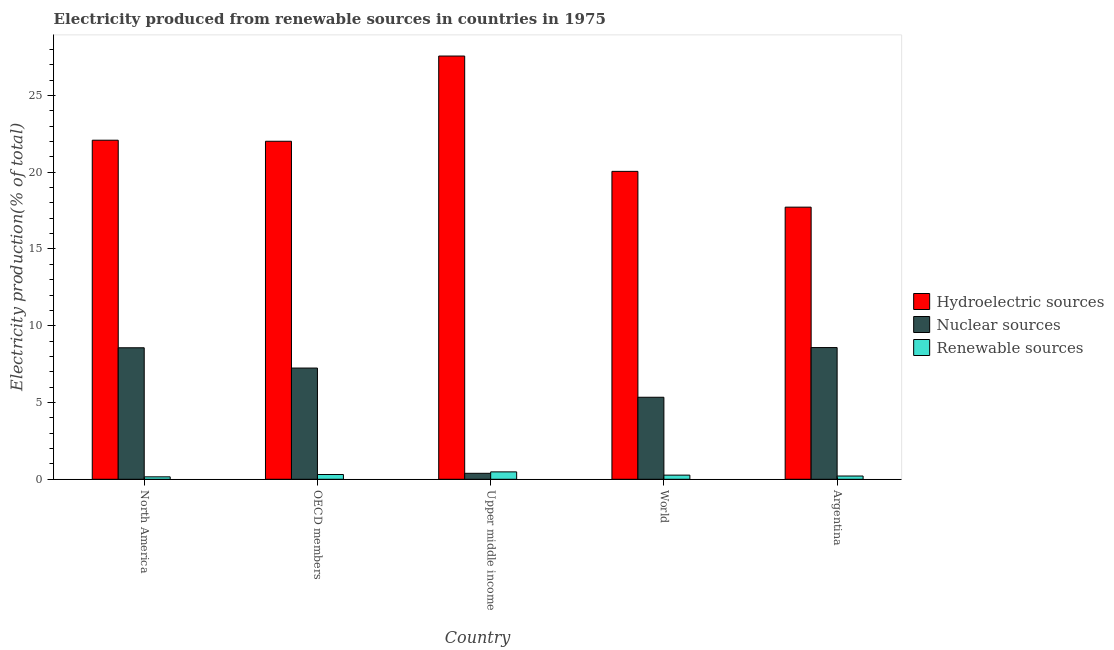Are the number of bars on each tick of the X-axis equal?
Your response must be concise. Yes. How many bars are there on the 3rd tick from the left?
Ensure brevity in your answer.  3. What is the label of the 3rd group of bars from the left?
Offer a very short reply. Upper middle income. What is the percentage of electricity produced by renewable sources in Upper middle income?
Give a very brief answer. 0.48. Across all countries, what is the maximum percentage of electricity produced by hydroelectric sources?
Your answer should be very brief. 27.57. Across all countries, what is the minimum percentage of electricity produced by renewable sources?
Your answer should be very brief. 0.16. In which country was the percentage of electricity produced by renewable sources maximum?
Give a very brief answer. Upper middle income. What is the total percentage of electricity produced by renewable sources in the graph?
Make the answer very short. 1.43. What is the difference between the percentage of electricity produced by nuclear sources in North America and that in World?
Provide a succinct answer. 3.22. What is the difference between the percentage of electricity produced by nuclear sources in Argentina and the percentage of electricity produced by renewable sources in Upper middle income?
Provide a short and direct response. 8.1. What is the average percentage of electricity produced by hydroelectric sources per country?
Give a very brief answer. 21.89. What is the difference between the percentage of electricity produced by nuclear sources and percentage of electricity produced by hydroelectric sources in OECD members?
Provide a succinct answer. -14.77. What is the ratio of the percentage of electricity produced by renewable sources in Upper middle income to that in World?
Ensure brevity in your answer.  1.79. What is the difference between the highest and the second highest percentage of electricity produced by hydroelectric sources?
Your answer should be compact. 5.48. What is the difference between the highest and the lowest percentage of electricity produced by nuclear sources?
Provide a short and direct response. 8.19. What does the 1st bar from the left in North America represents?
Make the answer very short. Hydroelectric sources. What does the 2nd bar from the right in World represents?
Give a very brief answer. Nuclear sources. Does the graph contain any zero values?
Your answer should be compact. No. Does the graph contain grids?
Give a very brief answer. No. Where does the legend appear in the graph?
Offer a very short reply. Center right. How are the legend labels stacked?
Keep it short and to the point. Vertical. What is the title of the graph?
Keep it short and to the point. Electricity produced from renewable sources in countries in 1975. Does "Services" appear as one of the legend labels in the graph?
Give a very brief answer. No. What is the Electricity production(% of total) in Hydroelectric sources in North America?
Provide a short and direct response. 22.08. What is the Electricity production(% of total) in Nuclear sources in North America?
Ensure brevity in your answer.  8.57. What is the Electricity production(% of total) of Renewable sources in North America?
Your answer should be very brief. 0.16. What is the Electricity production(% of total) of Hydroelectric sources in OECD members?
Offer a very short reply. 22.02. What is the Electricity production(% of total) of Nuclear sources in OECD members?
Keep it short and to the point. 7.24. What is the Electricity production(% of total) in Renewable sources in OECD members?
Provide a short and direct response. 0.31. What is the Electricity production(% of total) of Hydroelectric sources in Upper middle income?
Provide a succinct answer. 27.57. What is the Electricity production(% of total) of Nuclear sources in Upper middle income?
Ensure brevity in your answer.  0.39. What is the Electricity production(% of total) of Renewable sources in Upper middle income?
Keep it short and to the point. 0.48. What is the Electricity production(% of total) in Hydroelectric sources in World?
Your answer should be compact. 20.06. What is the Electricity production(% of total) of Nuclear sources in World?
Keep it short and to the point. 5.34. What is the Electricity production(% of total) in Renewable sources in World?
Make the answer very short. 0.27. What is the Electricity production(% of total) of Hydroelectric sources in Argentina?
Your answer should be very brief. 17.72. What is the Electricity production(% of total) in Nuclear sources in Argentina?
Ensure brevity in your answer.  8.58. What is the Electricity production(% of total) in Renewable sources in Argentina?
Provide a short and direct response. 0.21. Across all countries, what is the maximum Electricity production(% of total) in Hydroelectric sources?
Keep it short and to the point. 27.57. Across all countries, what is the maximum Electricity production(% of total) of Nuclear sources?
Your response must be concise. 8.58. Across all countries, what is the maximum Electricity production(% of total) in Renewable sources?
Your answer should be very brief. 0.48. Across all countries, what is the minimum Electricity production(% of total) of Hydroelectric sources?
Keep it short and to the point. 17.72. Across all countries, what is the minimum Electricity production(% of total) of Nuclear sources?
Provide a short and direct response. 0.39. Across all countries, what is the minimum Electricity production(% of total) of Renewable sources?
Your answer should be very brief. 0.16. What is the total Electricity production(% of total) in Hydroelectric sources in the graph?
Provide a succinct answer. 109.45. What is the total Electricity production(% of total) of Nuclear sources in the graph?
Offer a terse response. 30.12. What is the total Electricity production(% of total) of Renewable sources in the graph?
Give a very brief answer. 1.43. What is the difference between the Electricity production(% of total) of Hydroelectric sources in North America and that in OECD members?
Make the answer very short. 0.07. What is the difference between the Electricity production(% of total) of Nuclear sources in North America and that in OECD members?
Give a very brief answer. 1.32. What is the difference between the Electricity production(% of total) in Renewable sources in North America and that in OECD members?
Your response must be concise. -0.15. What is the difference between the Electricity production(% of total) in Hydroelectric sources in North America and that in Upper middle income?
Give a very brief answer. -5.48. What is the difference between the Electricity production(% of total) of Nuclear sources in North America and that in Upper middle income?
Provide a succinct answer. 8.18. What is the difference between the Electricity production(% of total) of Renewable sources in North America and that in Upper middle income?
Ensure brevity in your answer.  -0.32. What is the difference between the Electricity production(% of total) in Hydroelectric sources in North America and that in World?
Provide a short and direct response. 2.03. What is the difference between the Electricity production(% of total) in Nuclear sources in North America and that in World?
Give a very brief answer. 3.22. What is the difference between the Electricity production(% of total) of Renewable sources in North America and that in World?
Provide a succinct answer. -0.11. What is the difference between the Electricity production(% of total) in Hydroelectric sources in North America and that in Argentina?
Ensure brevity in your answer.  4.36. What is the difference between the Electricity production(% of total) of Nuclear sources in North America and that in Argentina?
Offer a terse response. -0.01. What is the difference between the Electricity production(% of total) in Renewable sources in North America and that in Argentina?
Offer a very short reply. -0.05. What is the difference between the Electricity production(% of total) in Hydroelectric sources in OECD members and that in Upper middle income?
Offer a very short reply. -5.55. What is the difference between the Electricity production(% of total) of Nuclear sources in OECD members and that in Upper middle income?
Offer a terse response. 6.85. What is the difference between the Electricity production(% of total) of Renewable sources in OECD members and that in Upper middle income?
Your answer should be very brief. -0.17. What is the difference between the Electricity production(% of total) of Hydroelectric sources in OECD members and that in World?
Keep it short and to the point. 1.96. What is the difference between the Electricity production(% of total) in Nuclear sources in OECD members and that in World?
Provide a succinct answer. 1.9. What is the difference between the Electricity production(% of total) in Renewable sources in OECD members and that in World?
Your response must be concise. 0.04. What is the difference between the Electricity production(% of total) in Hydroelectric sources in OECD members and that in Argentina?
Keep it short and to the point. 4.29. What is the difference between the Electricity production(% of total) in Nuclear sources in OECD members and that in Argentina?
Offer a terse response. -1.33. What is the difference between the Electricity production(% of total) in Renewable sources in OECD members and that in Argentina?
Provide a succinct answer. 0.1. What is the difference between the Electricity production(% of total) of Hydroelectric sources in Upper middle income and that in World?
Keep it short and to the point. 7.51. What is the difference between the Electricity production(% of total) in Nuclear sources in Upper middle income and that in World?
Give a very brief answer. -4.95. What is the difference between the Electricity production(% of total) in Renewable sources in Upper middle income and that in World?
Keep it short and to the point. 0.21. What is the difference between the Electricity production(% of total) in Hydroelectric sources in Upper middle income and that in Argentina?
Provide a succinct answer. 9.84. What is the difference between the Electricity production(% of total) of Nuclear sources in Upper middle income and that in Argentina?
Your answer should be very brief. -8.19. What is the difference between the Electricity production(% of total) of Renewable sources in Upper middle income and that in Argentina?
Offer a terse response. 0.27. What is the difference between the Electricity production(% of total) of Hydroelectric sources in World and that in Argentina?
Offer a very short reply. 2.33. What is the difference between the Electricity production(% of total) of Nuclear sources in World and that in Argentina?
Your answer should be compact. -3.24. What is the difference between the Electricity production(% of total) in Renewable sources in World and that in Argentina?
Ensure brevity in your answer.  0.06. What is the difference between the Electricity production(% of total) in Hydroelectric sources in North America and the Electricity production(% of total) in Nuclear sources in OECD members?
Provide a short and direct response. 14.84. What is the difference between the Electricity production(% of total) in Hydroelectric sources in North America and the Electricity production(% of total) in Renewable sources in OECD members?
Make the answer very short. 21.77. What is the difference between the Electricity production(% of total) of Nuclear sources in North America and the Electricity production(% of total) of Renewable sources in OECD members?
Provide a succinct answer. 8.25. What is the difference between the Electricity production(% of total) in Hydroelectric sources in North America and the Electricity production(% of total) in Nuclear sources in Upper middle income?
Make the answer very short. 21.7. What is the difference between the Electricity production(% of total) of Hydroelectric sources in North America and the Electricity production(% of total) of Renewable sources in Upper middle income?
Ensure brevity in your answer.  21.6. What is the difference between the Electricity production(% of total) of Nuclear sources in North America and the Electricity production(% of total) of Renewable sources in Upper middle income?
Your answer should be compact. 8.08. What is the difference between the Electricity production(% of total) of Hydroelectric sources in North America and the Electricity production(% of total) of Nuclear sources in World?
Provide a succinct answer. 16.74. What is the difference between the Electricity production(% of total) in Hydroelectric sources in North America and the Electricity production(% of total) in Renewable sources in World?
Make the answer very short. 21.81. What is the difference between the Electricity production(% of total) of Nuclear sources in North America and the Electricity production(% of total) of Renewable sources in World?
Your answer should be compact. 8.3. What is the difference between the Electricity production(% of total) of Hydroelectric sources in North America and the Electricity production(% of total) of Nuclear sources in Argentina?
Your answer should be very brief. 13.51. What is the difference between the Electricity production(% of total) of Hydroelectric sources in North America and the Electricity production(% of total) of Renewable sources in Argentina?
Your answer should be very brief. 21.87. What is the difference between the Electricity production(% of total) of Nuclear sources in North America and the Electricity production(% of total) of Renewable sources in Argentina?
Offer a very short reply. 8.35. What is the difference between the Electricity production(% of total) in Hydroelectric sources in OECD members and the Electricity production(% of total) in Nuclear sources in Upper middle income?
Give a very brief answer. 21.63. What is the difference between the Electricity production(% of total) of Hydroelectric sources in OECD members and the Electricity production(% of total) of Renewable sources in Upper middle income?
Offer a terse response. 21.53. What is the difference between the Electricity production(% of total) in Nuclear sources in OECD members and the Electricity production(% of total) in Renewable sources in Upper middle income?
Your response must be concise. 6.76. What is the difference between the Electricity production(% of total) in Hydroelectric sources in OECD members and the Electricity production(% of total) in Nuclear sources in World?
Your answer should be very brief. 16.67. What is the difference between the Electricity production(% of total) in Hydroelectric sources in OECD members and the Electricity production(% of total) in Renewable sources in World?
Ensure brevity in your answer.  21.75. What is the difference between the Electricity production(% of total) in Nuclear sources in OECD members and the Electricity production(% of total) in Renewable sources in World?
Offer a terse response. 6.97. What is the difference between the Electricity production(% of total) of Hydroelectric sources in OECD members and the Electricity production(% of total) of Nuclear sources in Argentina?
Offer a terse response. 13.44. What is the difference between the Electricity production(% of total) of Hydroelectric sources in OECD members and the Electricity production(% of total) of Renewable sources in Argentina?
Your answer should be very brief. 21.8. What is the difference between the Electricity production(% of total) in Nuclear sources in OECD members and the Electricity production(% of total) in Renewable sources in Argentina?
Make the answer very short. 7.03. What is the difference between the Electricity production(% of total) in Hydroelectric sources in Upper middle income and the Electricity production(% of total) in Nuclear sources in World?
Offer a very short reply. 22.23. What is the difference between the Electricity production(% of total) in Hydroelectric sources in Upper middle income and the Electricity production(% of total) in Renewable sources in World?
Your answer should be very brief. 27.3. What is the difference between the Electricity production(% of total) in Nuclear sources in Upper middle income and the Electricity production(% of total) in Renewable sources in World?
Your response must be concise. 0.12. What is the difference between the Electricity production(% of total) in Hydroelectric sources in Upper middle income and the Electricity production(% of total) in Nuclear sources in Argentina?
Provide a short and direct response. 18.99. What is the difference between the Electricity production(% of total) in Hydroelectric sources in Upper middle income and the Electricity production(% of total) in Renewable sources in Argentina?
Give a very brief answer. 27.36. What is the difference between the Electricity production(% of total) in Nuclear sources in Upper middle income and the Electricity production(% of total) in Renewable sources in Argentina?
Make the answer very short. 0.18. What is the difference between the Electricity production(% of total) of Hydroelectric sources in World and the Electricity production(% of total) of Nuclear sources in Argentina?
Keep it short and to the point. 11.48. What is the difference between the Electricity production(% of total) of Hydroelectric sources in World and the Electricity production(% of total) of Renewable sources in Argentina?
Offer a terse response. 19.84. What is the difference between the Electricity production(% of total) of Nuclear sources in World and the Electricity production(% of total) of Renewable sources in Argentina?
Offer a very short reply. 5.13. What is the average Electricity production(% of total) in Hydroelectric sources per country?
Ensure brevity in your answer.  21.89. What is the average Electricity production(% of total) of Nuclear sources per country?
Offer a terse response. 6.02. What is the average Electricity production(% of total) of Renewable sources per country?
Offer a terse response. 0.29. What is the difference between the Electricity production(% of total) of Hydroelectric sources and Electricity production(% of total) of Nuclear sources in North America?
Offer a very short reply. 13.52. What is the difference between the Electricity production(% of total) in Hydroelectric sources and Electricity production(% of total) in Renewable sources in North America?
Your answer should be very brief. 21.93. What is the difference between the Electricity production(% of total) of Nuclear sources and Electricity production(% of total) of Renewable sources in North America?
Your answer should be very brief. 8.41. What is the difference between the Electricity production(% of total) in Hydroelectric sources and Electricity production(% of total) in Nuclear sources in OECD members?
Your answer should be compact. 14.77. What is the difference between the Electricity production(% of total) of Hydroelectric sources and Electricity production(% of total) of Renewable sources in OECD members?
Offer a terse response. 21.7. What is the difference between the Electricity production(% of total) in Nuclear sources and Electricity production(% of total) in Renewable sources in OECD members?
Your answer should be very brief. 6.93. What is the difference between the Electricity production(% of total) in Hydroelectric sources and Electricity production(% of total) in Nuclear sources in Upper middle income?
Your answer should be compact. 27.18. What is the difference between the Electricity production(% of total) in Hydroelectric sources and Electricity production(% of total) in Renewable sources in Upper middle income?
Provide a succinct answer. 27.09. What is the difference between the Electricity production(% of total) of Nuclear sources and Electricity production(% of total) of Renewable sources in Upper middle income?
Make the answer very short. -0.09. What is the difference between the Electricity production(% of total) of Hydroelectric sources and Electricity production(% of total) of Nuclear sources in World?
Give a very brief answer. 14.71. What is the difference between the Electricity production(% of total) of Hydroelectric sources and Electricity production(% of total) of Renewable sources in World?
Ensure brevity in your answer.  19.79. What is the difference between the Electricity production(% of total) of Nuclear sources and Electricity production(% of total) of Renewable sources in World?
Make the answer very short. 5.07. What is the difference between the Electricity production(% of total) in Hydroelectric sources and Electricity production(% of total) in Nuclear sources in Argentina?
Your response must be concise. 9.15. What is the difference between the Electricity production(% of total) in Hydroelectric sources and Electricity production(% of total) in Renewable sources in Argentina?
Make the answer very short. 17.51. What is the difference between the Electricity production(% of total) of Nuclear sources and Electricity production(% of total) of Renewable sources in Argentina?
Offer a terse response. 8.37. What is the ratio of the Electricity production(% of total) in Nuclear sources in North America to that in OECD members?
Give a very brief answer. 1.18. What is the ratio of the Electricity production(% of total) in Renewable sources in North America to that in OECD members?
Give a very brief answer. 0.51. What is the ratio of the Electricity production(% of total) of Hydroelectric sources in North America to that in Upper middle income?
Offer a very short reply. 0.8. What is the ratio of the Electricity production(% of total) of Nuclear sources in North America to that in Upper middle income?
Offer a terse response. 22.02. What is the ratio of the Electricity production(% of total) in Renewable sources in North America to that in Upper middle income?
Provide a succinct answer. 0.33. What is the ratio of the Electricity production(% of total) of Hydroelectric sources in North America to that in World?
Provide a short and direct response. 1.1. What is the ratio of the Electricity production(% of total) in Nuclear sources in North America to that in World?
Make the answer very short. 1.6. What is the ratio of the Electricity production(% of total) in Renewable sources in North America to that in World?
Your answer should be compact. 0.59. What is the ratio of the Electricity production(% of total) in Hydroelectric sources in North America to that in Argentina?
Offer a very short reply. 1.25. What is the ratio of the Electricity production(% of total) in Nuclear sources in North America to that in Argentina?
Ensure brevity in your answer.  1. What is the ratio of the Electricity production(% of total) of Renewable sources in North America to that in Argentina?
Give a very brief answer. 0.75. What is the ratio of the Electricity production(% of total) in Hydroelectric sources in OECD members to that in Upper middle income?
Make the answer very short. 0.8. What is the ratio of the Electricity production(% of total) of Nuclear sources in OECD members to that in Upper middle income?
Ensure brevity in your answer.  18.62. What is the ratio of the Electricity production(% of total) of Renewable sources in OECD members to that in Upper middle income?
Your answer should be compact. 0.65. What is the ratio of the Electricity production(% of total) in Hydroelectric sources in OECD members to that in World?
Keep it short and to the point. 1.1. What is the ratio of the Electricity production(% of total) of Nuclear sources in OECD members to that in World?
Provide a short and direct response. 1.36. What is the ratio of the Electricity production(% of total) of Renewable sources in OECD members to that in World?
Your answer should be compact. 1.15. What is the ratio of the Electricity production(% of total) in Hydroelectric sources in OECD members to that in Argentina?
Offer a very short reply. 1.24. What is the ratio of the Electricity production(% of total) in Nuclear sources in OECD members to that in Argentina?
Provide a succinct answer. 0.84. What is the ratio of the Electricity production(% of total) in Renewable sources in OECD members to that in Argentina?
Your answer should be very brief. 1.47. What is the ratio of the Electricity production(% of total) in Hydroelectric sources in Upper middle income to that in World?
Your answer should be compact. 1.37. What is the ratio of the Electricity production(% of total) in Nuclear sources in Upper middle income to that in World?
Offer a terse response. 0.07. What is the ratio of the Electricity production(% of total) of Renewable sources in Upper middle income to that in World?
Offer a terse response. 1.79. What is the ratio of the Electricity production(% of total) in Hydroelectric sources in Upper middle income to that in Argentina?
Provide a succinct answer. 1.56. What is the ratio of the Electricity production(% of total) in Nuclear sources in Upper middle income to that in Argentina?
Your answer should be compact. 0.05. What is the ratio of the Electricity production(% of total) of Renewable sources in Upper middle income to that in Argentina?
Provide a short and direct response. 2.28. What is the ratio of the Electricity production(% of total) in Hydroelectric sources in World to that in Argentina?
Offer a very short reply. 1.13. What is the ratio of the Electricity production(% of total) in Nuclear sources in World to that in Argentina?
Make the answer very short. 0.62. What is the ratio of the Electricity production(% of total) of Renewable sources in World to that in Argentina?
Keep it short and to the point. 1.28. What is the difference between the highest and the second highest Electricity production(% of total) in Hydroelectric sources?
Offer a very short reply. 5.48. What is the difference between the highest and the second highest Electricity production(% of total) in Nuclear sources?
Offer a terse response. 0.01. What is the difference between the highest and the second highest Electricity production(% of total) of Renewable sources?
Offer a very short reply. 0.17. What is the difference between the highest and the lowest Electricity production(% of total) of Hydroelectric sources?
Make the answer very short. 9.84. What is the difference between the highest and the lowest Electricity production(% of total) in Nuclear sources?
Make the answer very short. 8.19. What is the difference between the highest and the lowest Electricity production(% of total) in Renewable sources?
Your answer should be compact. 0.32. 